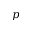<formula> <loc_0><loc_0><loc_500><loc_500>p</formula> 